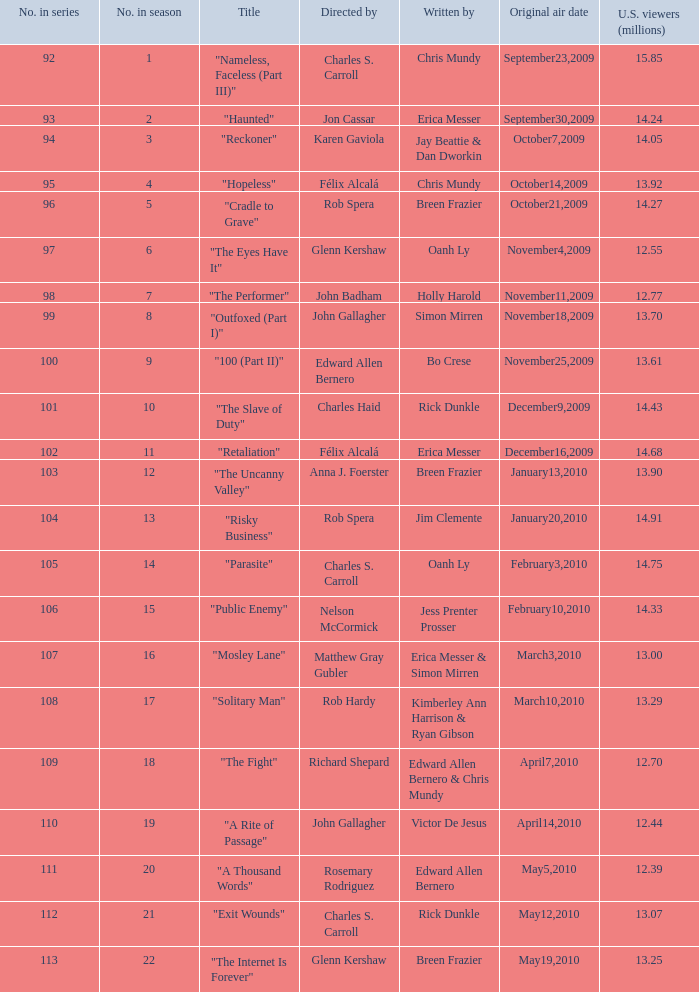What was the first episode in the season directed by nelson mccormick? 15.0. 